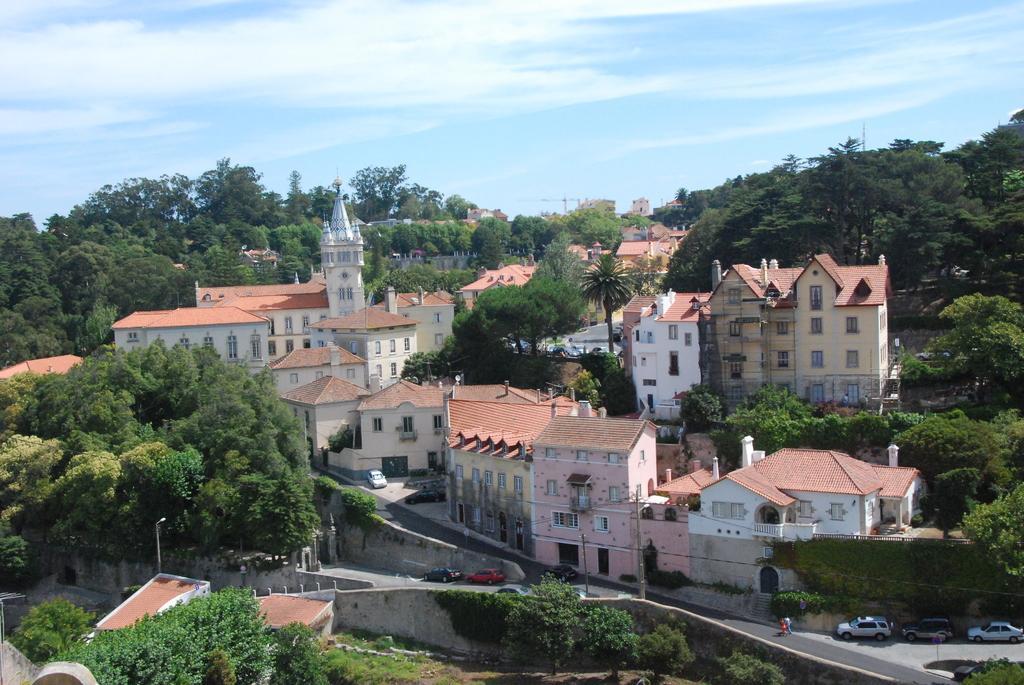Could you give a brief overview of what you see in this image? The picture is aerial view of a city or a town. In this picture there are trees, buildings, cars, street lights, roads and other objects. Sky is partially cloudy. 